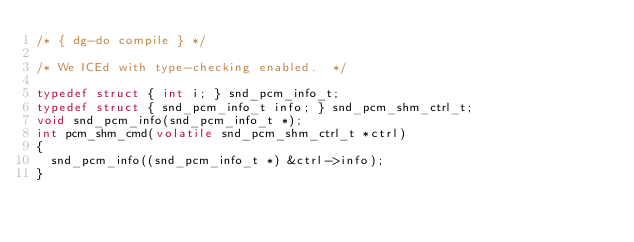<code> <loc_0><loc_0><loc_500><loc_500><_C_>/* { dg-do compile } */

/* We ICEd with type-checking enabled.  */

typedef struct { int i; } snd_pcm_info_t;
typedef struct { snd_pcm_info_t info; } snd_pcm_shm_ctrl_t;
void snd_pcm_info(snd_pcm_info_t *);
int pcm_shm_cmd(volatile snd_pcm_shm_ctrl_t *ctrl)
{
  snd_pcm_info((snd_pcm_info_t *) &ctrl->info);
}

</code> 